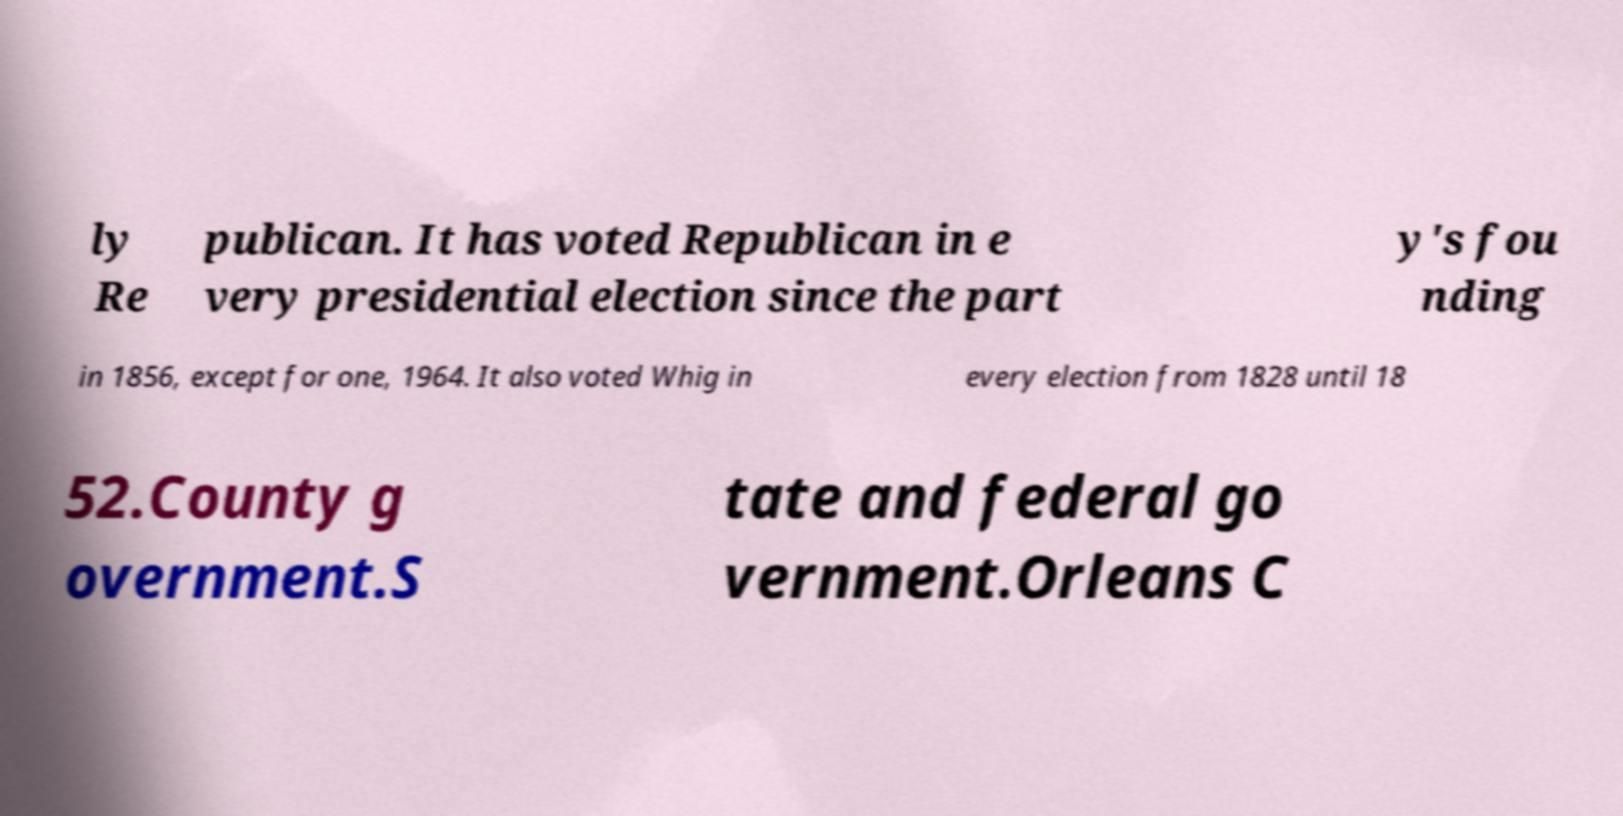Please identify and transcribe the text found in this image. ly Re publican. It has voted Republican in e very presidential election since the part y's fou nding in 1856, except for one, 1964. It also voted Whig in every election from 1828 until 18 52.County g overnment.S tate and federal go vernment.Orleans C 